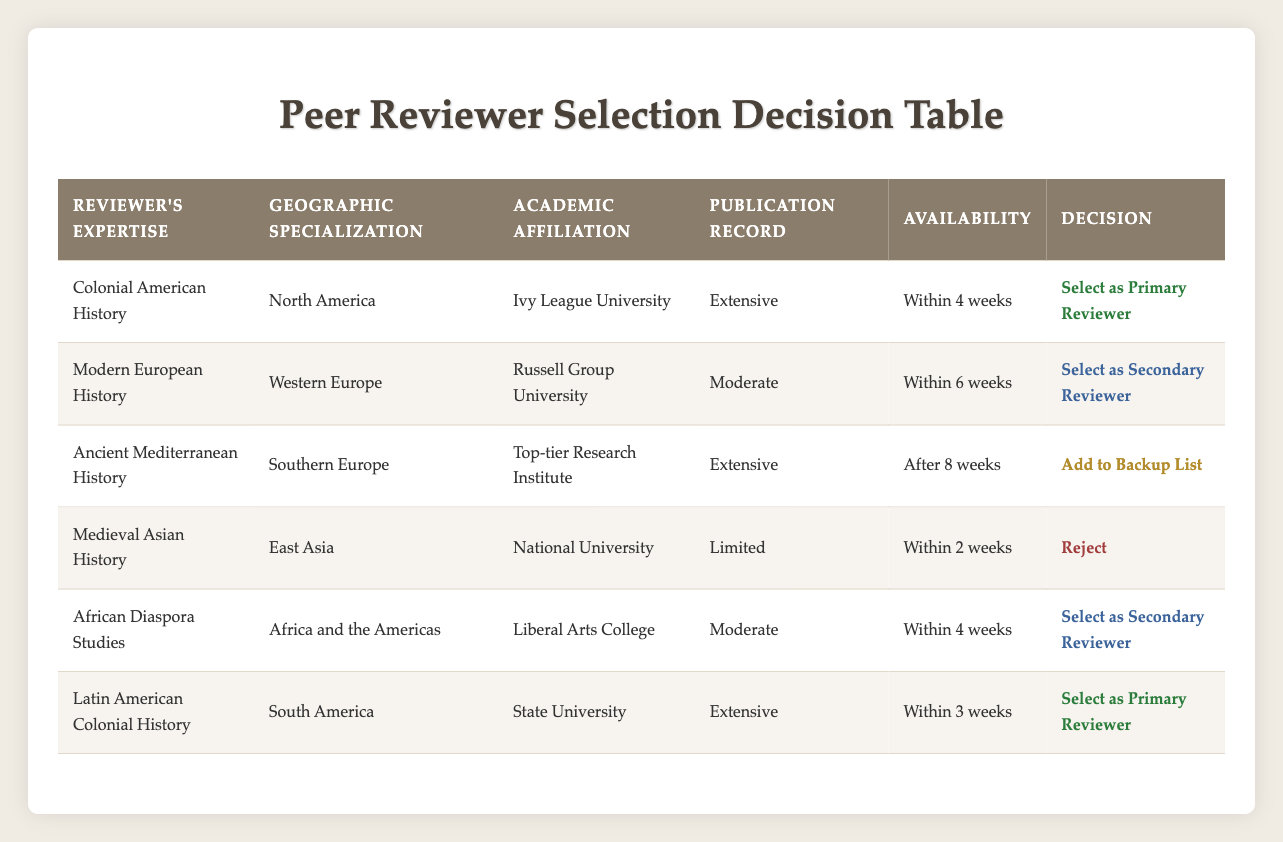What is the academic affiliation of the primary reviewer for Colonial American History? According to the table, the primary reviewer for Colonial American History is affiliated with an Ivy League University.
Answer: Ivy League University Which reviewer has a publication record classified as "Limited"? The reviewer listed as having a publication record of "Limited" is the one specializing in Medieval Asian History.
Answer: Medieval Asian History Is there a reviewer for Latin American Colonial History? Yes, the table indicates that there is a reviewer for Latin American Colonial History, who has an extensive publication record and is selected as a primary reviewer.
Answer: Yes How many reviewers are selected as secondary reviewers? There are two reviewers selected as secondary reviewers: one for Modern European History and the other for African Diaspora Studies.
Answer: 2 What is the geographic specialization of the reviewer with the highest publication record? The reviewers with the highest publication record—Colonial American History, Ancient Mediterranean History, and Latin American Colonial History—specialize in North America, Southern Europe, and South America, respectively. Therefore, it encompasses these geographic areas.
Answer: North America, Southern Europe, South America If we consider availability, how many reviewers can be selected within 4 weeks? By examining the availability column, there are four reviewers who can be selected within 4 weeks: Colonial American History, African Diaspora Studies, and Latin American Colonial History.
Answer: 4 What is the decision for the reviewer affiliated with a Liberal Arts College? The reviewer from a Liberal Arts College, specializing in African Diaspora Studies, is selected as a secondary reviewer according to the table.
Answer: Select as Secondary Reviewer Which geographic specialization has no reviewer selected as a primary reviewer? The table shows that the geographic specialization of East Asia does not have a reviewer selected as a primary reviewer.
Answer: East Asia Among the reviewers listed, who has the longest availability period before they can review? The reviewer with the longest availability period is the one specializing in Ancient Mediterranean History, available after 8 weeks.
Answer: Ancient Mediterranean History 